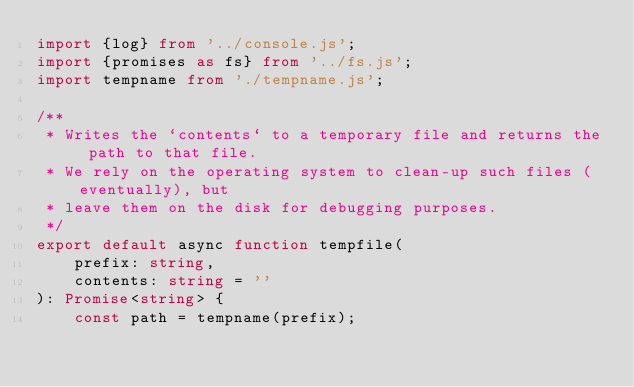Convert code to text. <code><loc_0><loc_0><loc_500><loc_500><_TypeScript_>import {log} from '../console.js';
import {promises as fs} from '../fs.js';
import tempname from './tempname.js';

/**
 * Writes the `contents` to a temporary file and returns the path to that file.
 * We rely on the operating system to clean-up such files (eventually), but
 * leave them on the disk for debugging purposes.
 */
export default async function tempfile(
    prefix: string,
    contents: string = ''
): Promise<string> {
    const path = tempname(prefix);
</code> 